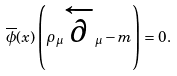Convert formula to latex. <formula><loc_0><loc_0><loc_500><loc_500>\overline { \phi } ( x ) \left ( \rho _ { \mu } \overleftarrow { \partial } _ { \mu } - m \right ) = 0 .</formula> 